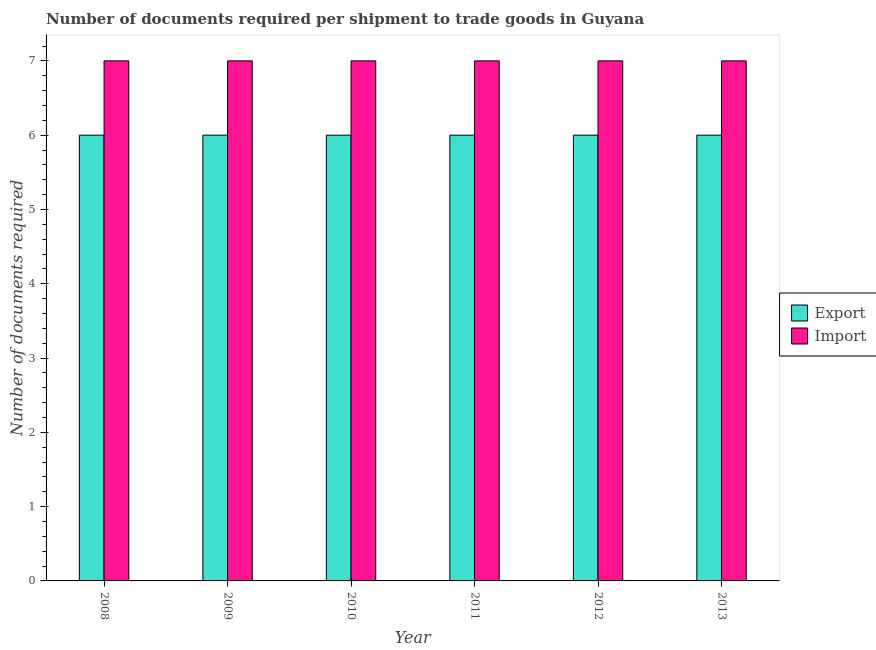Are the number of bars per tick equal to the number of legend labels?
Your answer should be very brief. Yes. How many bars are there on the 6th tick from the left?
Give a very brief answer. 2. How many bars are there on the 4th tick from the right?
Keep it short and to the point. 2. What is the number of documents required to export goods in 2010?
Your response must be concise. 6. Across all years, what is the maximum number of documents required to import goods?
Ensure brevity in your answer.  7. Across all years, what is the minimum number of documents required to export goods?
Your response must be concise. 6. What is the total number of documents required to import goods in the graph?
Provide a succinct answer. 42. What is the average number of documents required to export goods per year?
Your answer should be compact. 6. In how many years, is the number of documents required to export goods greater than 6.8?
Your answer should be very brief. 0. What is the ratio of the number of documents required to export goods in 2008 to that in 2010?
Make the answer very short. 1. Is the difference between the number of documents required to import goods in 2010 and 2013 greater than the difference between the number of documents required to export goods in 2010 and 2013?
Keep it short and to the point. No. What is the difference between the highest and the second highest number of documents required to import goods?
Give a very brief answer. 0. Is the sum of the number of documents required to import goods in 2009 and 2013 greater than the maximum number of documents required to export goods across all years?
Offer a terse response. Yes. What does the 2nd bar from the left in 2012 represents?
Keep it short and to the point. Import. What does the 1st bar from the right in 2011 represents?
Give a very brief answer. Import. How many bars are there?
Give a very brief answer. 12. Are the values on the major ticks of Y-axis written in scientific E-notation?
Ensure brevity in your answer.  No. Does the graph contain grids?
Offer a terse response. No. Where does the legend appear in the graph?
Provide a succinct answer. Center right. What is the title of the graph?
Make the answer very short. Number of documents required per shipment to trade goods in Guyana. What is the label or title of the Y-axis?
Your answer should be very brief. Number of documents required. What is the Number of documents required in Export in 2008?
Keep it short and to the point. 6. What is the Number of documents required of Import in 2008?
Your response must be concise. 7. What is the Number of documents required in Export in 2009?
Your response must be concise. 6. What is the Number of documents required in Export in 2010?
Provide a succinct answer. 6. What is the Number of documents required in Import in 2011?
Provide a succinct answer. 7. What is the Number of documents required of Export in 2012?
Provide a short and direct response. 6. What is the Number of documents required of Export in 2013?
Your answer should be very brief. 6. What is the Number of documents required of Import in 2013?
Offer a terse response. 7. Across all years, what is the maximum Number of documents required of Import?
Offer a very short reply. 7. Across all years, what is the minimum Number of documents required of Import?
Your answer should be very brief. 7. What is the difference between the Number of documents required in Export in 2008 and that in 2009?
Ensure brevity in your answer.  0. What is the difference between the Number of documents required of Import in 2008 and that in 2009?
Your response must be concise. 0. What is the difference between the Number of documents required in Import in 2008 and that in 2010?
Your answer should be compact. 0. What is the difference between the Number of documents required in Import in 2008 and that in 2011?
Offer a very short reply. 0. What is the difference between the Number of documents required of Export in 2008 and that in 2013?
Your answer should be very brief. 0. What is the difference between the Number of documents required in Export in 2009 and that in 2010?
Give a very brief answer. 0. What is the difference between the Number of documents required of Export in 2009 and that in 2011?
Give a very brief answer. 0. What is the difference between the Number of documents required in Export in 2009 and that in 2012?
Make the answer very short. 0. What is the difference between the Number of documents required in Import in 2009 and that in 2012?
Provide a short and direct response. 0. What is the difference between the Number of documents required of Import in 2010 and that in 2011?
Provide a succinct answer. 0. What is the difference between the Number of documents required in Export in 2010 and that in 2013?
Provide a short and direct response. 0. What is the difference between the Number of documents required of Export in 2011 and that in 2012?
Your answer should be very brief. 0. What is the difference between the Number of documents required in Export in 2011 and that in 2013?
Offer a terse response. 0. What is the difference between the Number of documents required in Import in 2011 and that in 2013?
Your answer should be very brief. 0. What is the difference between the Number of documents required in Import in 2012 and that in 2013?
Your answer should be compact. 0. What is the difference between the Number of documents required in Export in 2008 and the Number of documents required in Import in 2012?
Keep it short and to the point. -1. What is the difference between the Number of documents required in Export in 2009 and the Number of documents required in Import in 2010?
Make the answer very short. -1. What is the difference between the Number of documents required of Export in 2009 and the Number of documents required of Import in 2011?
Provide a succinct answer. -1. What is the difference between the Number of documents required of Export in 2009 and the Number of documents required of Import in 2012?
Make the answer very short. -1. What is the difference between the Number of documents required of Export in 2010 and the Number of documents required of Import in 2011?
Provide a succinct answer. -1. What is the difference between the Number of documents required of Export in 2010 and the Number of documents required of Import in 2013?
Provide a short and direct response. -1. What is the difference between the Number of documents required in Export in 2011 and the Number of documents required in Import in 2013?
Your answer should be very brief. -1. What is the average Number of documents required of Import per year?
Provide a succinct answer. 7. In the year 2009, what is the difference between the Number of documents required in Export and Number of documents required in Import?
Offer a terse response. -1. In the year 2010, what is the difference between the Number of documents required of Export and Number of documents required of Import?
Give a very brief answer. -1. In the year 2012, what is the difference between the Number of documents required of Export and Number of documents required of Import?
Offer a very short reply. -1. What is the ratio of the Number of documents required in Export in 2008 to that in 2009?
Make the answer very short. 1. What is the ratio of the Number of documents required in Import in 2008 to that in 2009?
Give a very brief answer. 1. What is the ratio of the Number of documents required of Export in 2008 to that in 2010?
Make the answer very short. 1. What is the ratio of the Number of documents required in Import in 2008 to that in 2010?
Give a very brief answer. 1. What is the ratio of the Number of documents required of Export in 2009 to that in 2010?
Offer a very short reply. 1. What is the ratio of the Number of documents required in Export in 2009 to that in 2012?
Keep it short and to the point. 1. What is the ratio of the Number of documents required of Import in 2009 to that in 2012?
Give a very brief answer. 1. What is the ratio of the Number of documents required in Import in 2009 to that in 2013?
Keep it short and to the point. 1. What is the ratio of the Number of documents required of Import in 2010 to that in 2011?
Give a very brief answer. 1. What is the ratio of the Number of documents required in Import in 2010 to that in 2012?
Keep it short and to the point. 1. What is the ratio of the Number of documents required in Export in 2010 to that in 2013?
Ensure brevity in your answer.  1. What is the ratio of the Number of documents required in Export in 2011 to that in 2012?
Offer a very short reply. 1. What is the ratio of the Number of documents required of Export in 2011 to that in 2013?
Offer a very short reply. 1. What is the difference between the highest and the second highest Number of documents required of Export?
Offer a terse response. 0. What is the difference between the highest and the second highest Number of documents required of Import?
Keep it short and to the point. 0. 